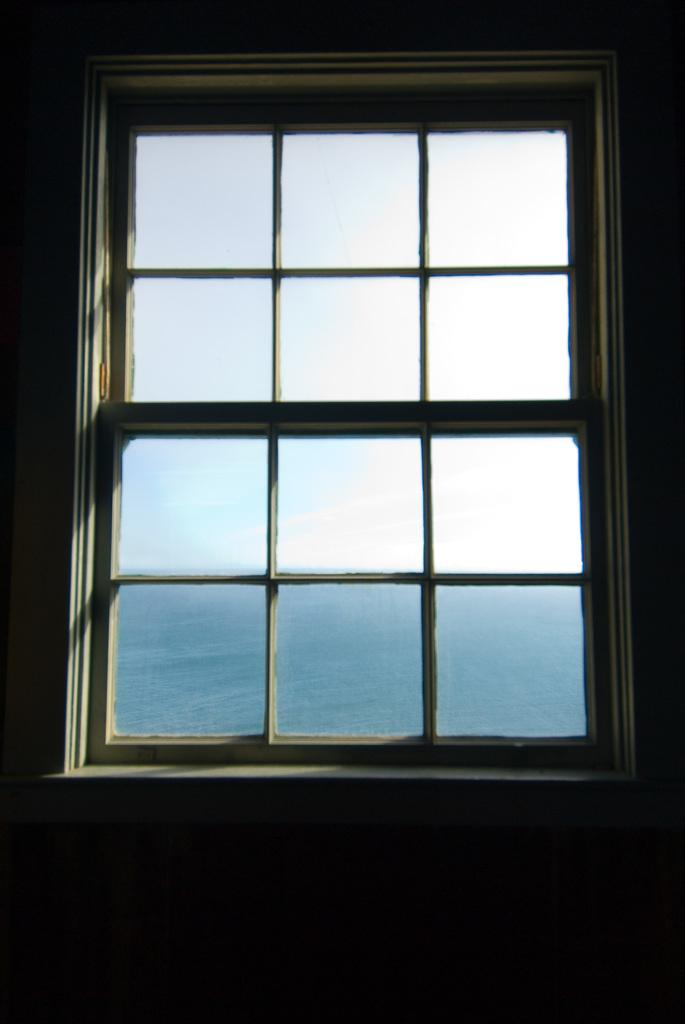What can be seen through the window in the image? The sky and water are visible through the window in the image. Can you describe the view from the window? The view from the window includes the sky and water. What type of calendar is hanging on the wall near the window? There is no calendar present in the image. 